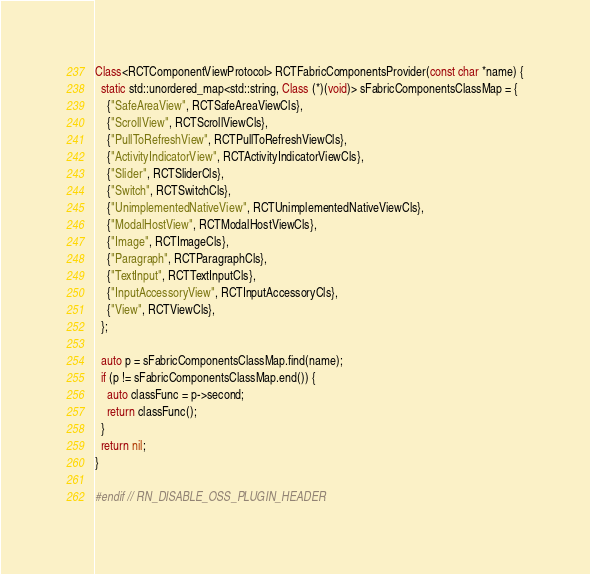<code> <loc_0><loc_0><loc_500><loc_500><_ObjectiveC_>Class<RCTComponentViewProtocol> RCTFabricComponentsProvider(const char *name) {
  static std::unordered_map<std::string, Class (*)(void)> sFabricComponentsClassMap = {
    {"SafeAreaView", RCTSafeAreaViewCls},
    {"ScrollView", RCTScrollViewCls},
    {"PullToRefreshView", RCTPullToRefreshViewCls},
    {"ActivityIndicatorView", RCTActivityIndicatorViewCls},
    {"Slider", RCTSliderCls},
    {"Switch", RCTSwitchCls},
    {"UnimplementedNativeView", RCTUnimplementedNativeViewCls},
    {"ModalHostView", RCTModalHostViewCls},
    {"Image", RCTImageCls},
    {"Paragraph", RCTParagraphCls},
    {"TextInput", RCTTextInputCls},
    {"InputAccessoryView", RCTInputAccessoryCls},
    {"View", RCTViewCls},
  };

  auto p = sFabricComponentsClassMap.find(name);
  if (p != sFabricComponentsClassMap.end()) {
    auto classFunc = p->second;
    return classFunc();
  }
  return nil;
}

#endif // RN_DISABLE_OSS_PLUGIN_HEADER
</code> 